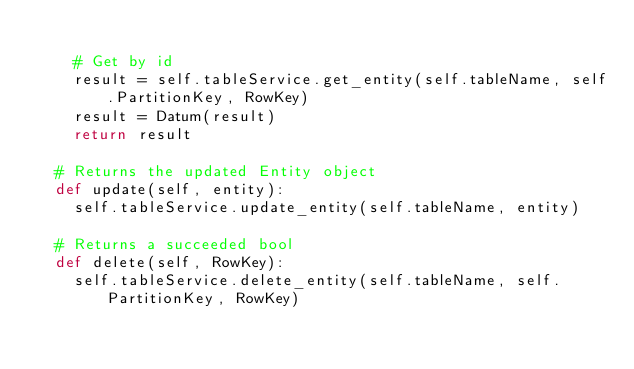<code> <loc_0><loc_0><loc_500><loc_500><_Python_>		
		# Get by id
		result = self.tableService.get_entity(self.tableName, self.PartitionKey, RowKey)
		result = Datum(result)
		return result

	# Returns the updated Entity object
	def update(self, entity):
		self.tableService.update_entity(self.tableName, entity)

	# Returns a succeeded bool
	def delete(self, RowKey):
		self.tableService.delete_entity(self.tableName, self.PartitionKey, RowKey)
	
</code> 